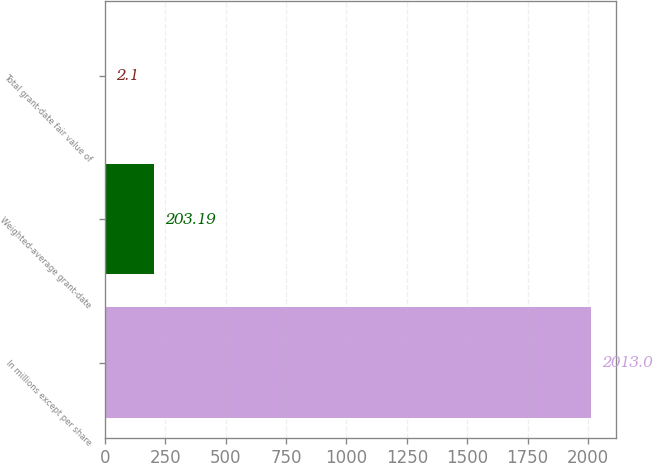Convert chart to OTSL. <chart><loc_0><loc_0><loc_500><loc_500><bar_chart><fcel>In millions except per share<fcel>Weighted-average grant-date<fcel>Total grant-date fair value of<nl><fcel>2013<fcel>203.19<fcel>2.1<nl></chart> 